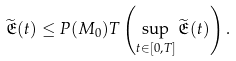Convert formula to latex. <formula><loc_0><loc_0><loc_500><loc_500>\widetilde { \mathfrak { E } } ( t ) \leq P ( M _ { 0 } ) T \left ( \sup _ { t \in [ 0 , T ] } \widetilde { \mathfrak { E } } ( t ) \right ) .</formula> 